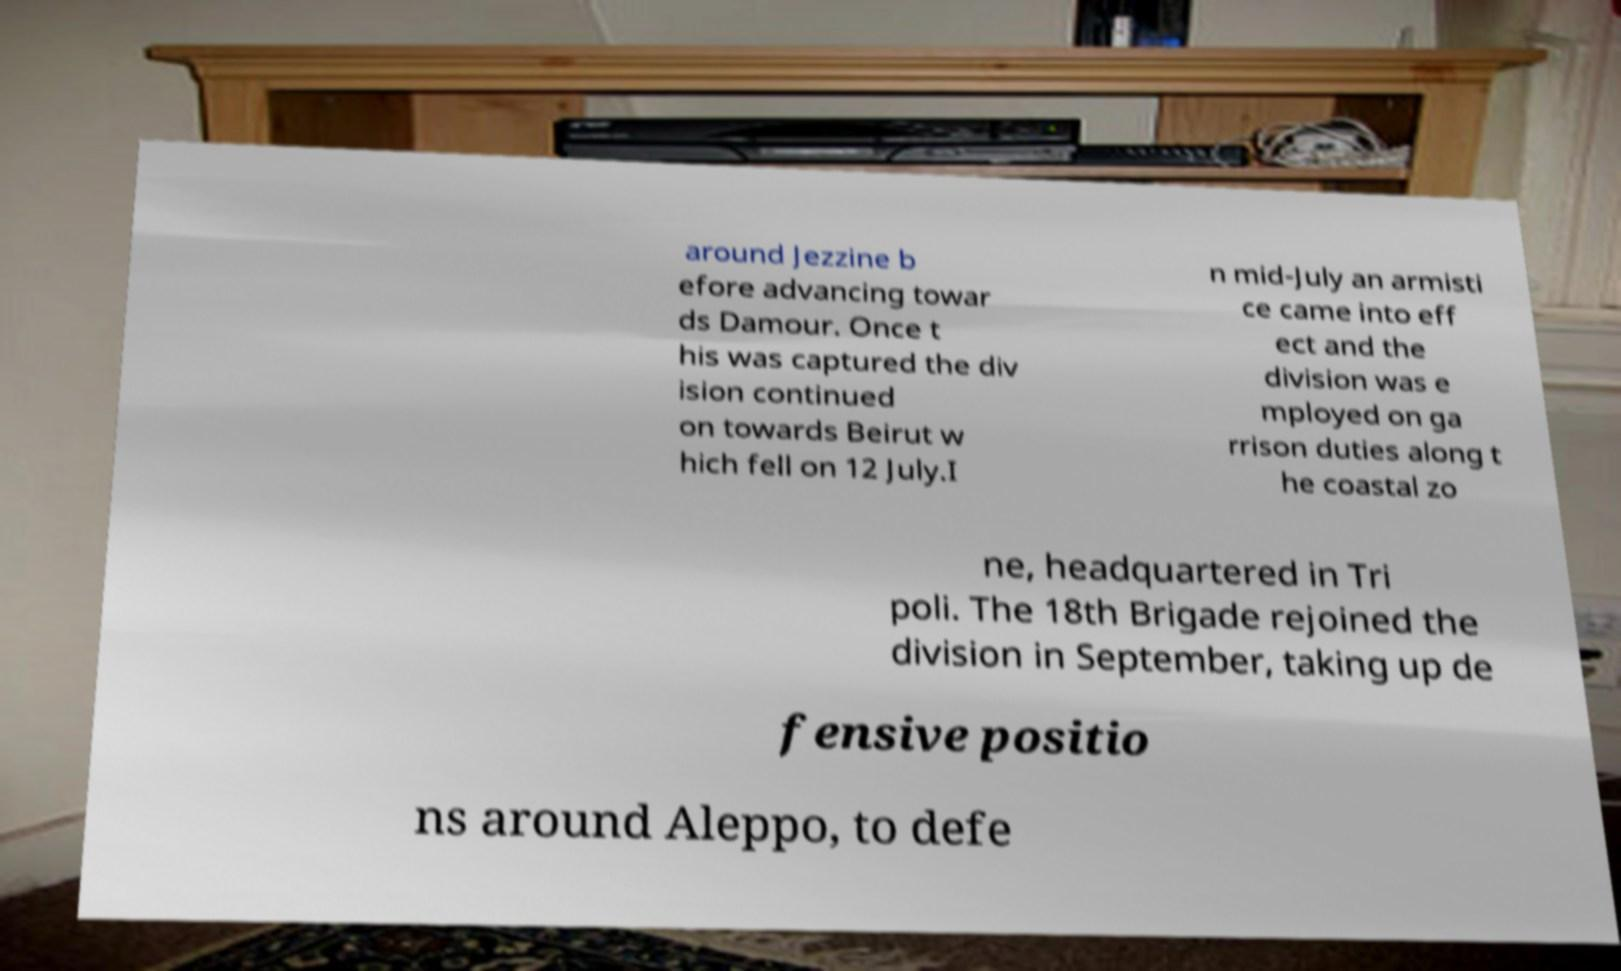Can you accurately transcribe the text from the provided image for me? around Jezzine b efore advancing towar ds Damour. Once t his was captured the div ision continued on towards Beirut w hich fell on 12 July.I n mid-July an armisti ce came into eff ect and the division was e mployed on ga rrison duties along t he coastal zo ne, headquartered in Tri poli. The 18th Brigade rejoined the division in September, taking up de fensive positio ns around Aleppo, to defe 